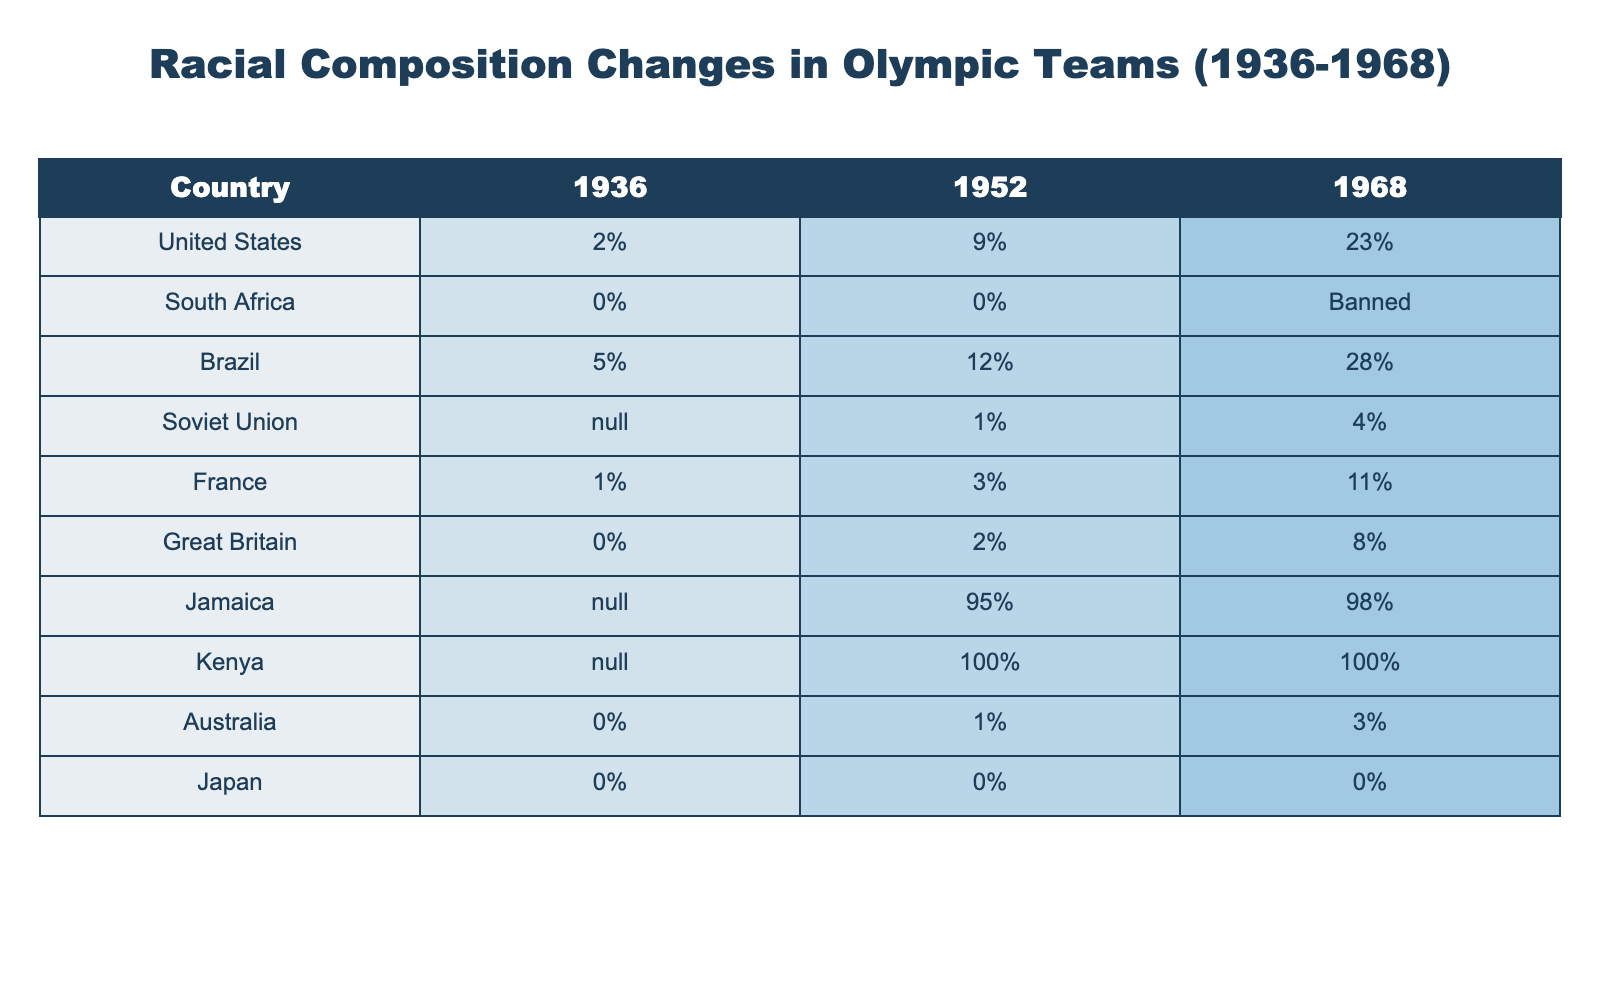What was the racial composition of the United States Olympic team in 1936? According to the table, the racial composition of the United States Olympic team in 1936 was 2%.
Answer: 2% Which country had the highest percentage of racial composition in 1968? By checking the table, Jamaica had the highest racial composition at 98% in 1968.
Answer: Jamaica Which country's Olympic team was banned from competing in 1968? The table indicates that South Africa was banned from the Olympics in 1968.
Answer: South Africa What is the difference in racial composition for Brazil between 1952 and 1968? The racial composition for Brazil was 12% in 1952 and 28% in 1968. The difference is 28% - 12% = 16%.
Answer: 16% What was the racial composition of the Soviet Union in 1952 and how did it change by 1968? The table shows the Soviet Union had a 1% racial composition in 1952 and increased to 4% in 1968.
Answer: Increased by 3% Did France's racial composition increase or decrease from 1936 to 1968? France had a composition of 1% in 1936 and 11% in 1968, which indicates an increase.
Answer: Increase What are the average racial compositions for the countries listed in 1968? To find the average, sum the compositions (23 + 0 + 28 + 4 + 11 + 8 + 98 + 100 + 3 + 0) = 275 and there are 10 countries, so the average is 275 / 10 = 27.5%.
Answer: 27.5% How did Jamaica's racial composition change from 1952 to 1968? Jamaica's racial composition was 95% in 1952 and 98% in 1968, indicating an increase of 3%.
Answer: Increased by 3% Which countries had a 0% racial composition in both 1936 and 1968? The countries Japan and South Africa had a 0% racial composition in both years, as per the table.
Answer: Japan, South Africa If we consider the countries listed, how many showed a racial composition of 0% in 1968? Looking at the table, only Japan had a 0% racial composition in 1968.
Answer: 1 